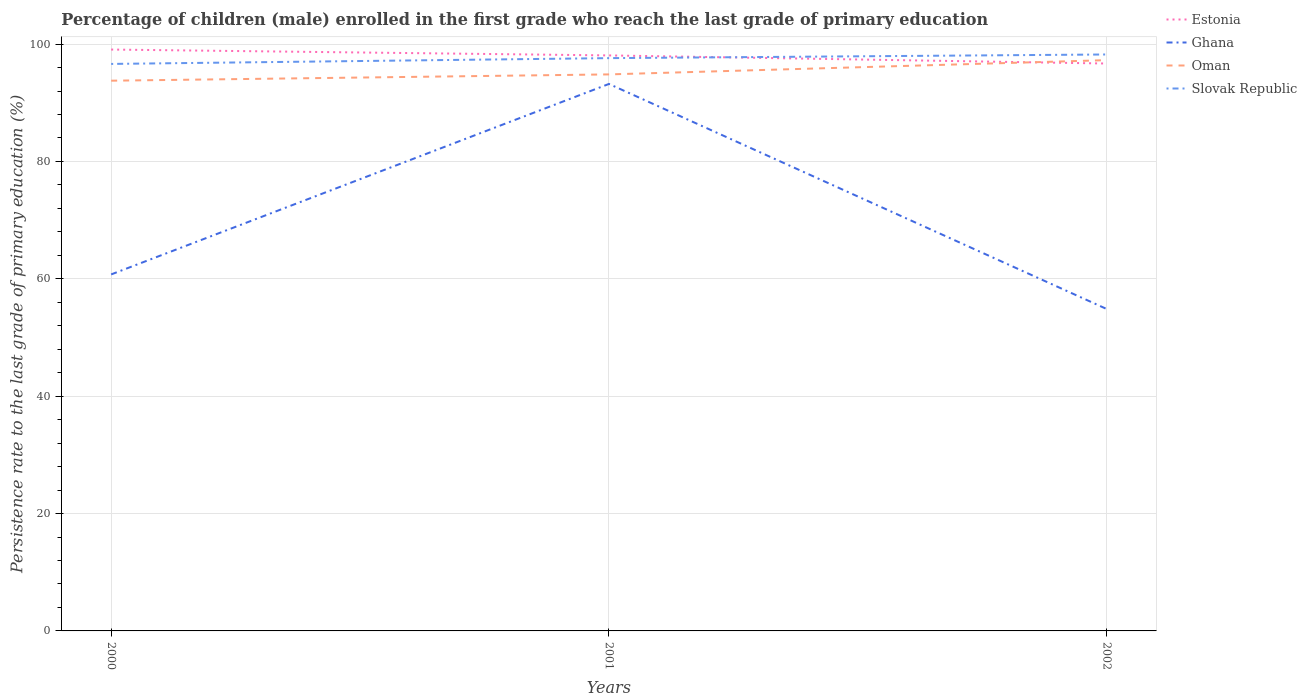Across all years, what is the maximum persistence rate of children in Slovak Republic?
Ensure brevity in your answer.  96.62. In which year was the persistence rate of children in Oman maximum?
Offer a terse response. 2000. What is the total persistence rate of children in Oman in the graph?
Provide a short and direct response. -2.43. What is the difference between the highest and the second highest persistence rate of children in Estonia?
Your answer should be compact. 2.38. How many years are there in the graph?
Your answer should be compact. 3. Are the values on the major ticks of Y-axis written in scientific E-notation?
Ensure brevity in your answer.  No. What is the title of the graph?
Ensure brevity in your answer.  Percentage of children (male) enrolled in the first grade who reach the last grade of primary education. Does "Guatemala" appear as one of the legend labels in the graph?
Offer a very short reply. No. What is the label or title of the X-axis?
Offer a very short reply. Years. What is the label or title of the Y-axis?
Your answer should be very brief. Persistence rate to the last grade of primary education (%). What is the Persistence rate to the last grade of primary education (%) of Estonia in 2000?
Offer a terse response. 99.07. What is the Persistence rate to the last grade of primary education (%) in Ghana in 2000?
Your answer should be compact. 60.75. What is the Persistence rate to the last grade of primary education (%) of Oman in 2000?
Your response must be concise. 93.76. What is the Persistence rate to the last grade of primary education (%) in Slovak Republic in 2000?
Your answer should be compact. 96.62. What is the Persistence rate to the last grade of primary education (%) of Estonia in 2001?
Your answer should be compact. 98.07. What is the Persistence rate to the last grade of primary education (%) of Ghana in 2001?
Offer a very short reply. 93.2. What is the Persistence rate to the last grade of primary education (%) in Oman in 2001?
Offer a terse response. 94.83. What is the Persistence rate to the last grade of primary education (%) of Slovak Republic in 2001?
Ensure brevity in your answer.  97.6. What is the Persistence rate to the last grade of primary education (%) of Estonia in 2002?
Your response must be concise. 96.68. What is the Persistence rate to the last grade of primary education (%) of Ghana in 2002?
Keep it short and to the point. 54.85. What is the Persistence rate to the last grade of primary education (%) in Oman in 2002?
Offer a very short reply. 97.26. What is the Persistence rate to the last grade of primary education (%) of Slovak Republic in 2002?
Make the answer very short. 98.23. Across all years, what is the maximum Persistence rate to the last grade of primary education (%) of Estonia?
Provide a short and direct response. 99.07. Across all years, what is the maximum Persistence rate to the last grade of primary education (%) in Ghana?
Keep it short and to the point. 93.2. Across all years, what is the maximum Persistence rate to the last grade of primary education (%) of Oman?
Offer a very short reply. 97.26. Across all years, what is the maximum Persistence rate to the last grade of primary education (%) of Slovak Republic?
Give a very brief answer. 98.23. Across all years, what is the minimum Persistence rate to the last grade of primary education (%) in Estonia?
Keep it short and to the point. 96.68. Across all years, what is the minimum Persistence rate to the last grade of primary education (%) in Ghana?
Make the answer very short. 54.85. Across all years, what is the minimum Persistence rate to the last grade of primary education (%) in Oman?
Keep it short and to the point. 93.76. Across all years, what is the minimum Persistence rate to the last grade of primary education (%) of Slovak Republic?
Give a very brief answer. 96.62. What is the total Persistence rate to the last grade of primary education (%) in Estonia in the graph?
Provide a short and direct response. 293.81. What is the total Persistence rate to the last grade of primary education (%) in Ghana in the graph?
Offer a terse response. 208.8. What is the total Persistence rate to the last grade of primary education (%) of Oman in the graph?
Your answer should be compact. 285.85. What is the total Persistence rate to the last grade of primary education (%) in Slovak Republic in the graph?
Ensure brevity in your answer.  292.44. What is the difference between the Persistence rate to the last grade of primary education (%) of Ghana in 2000 and that in 2001?
Provide a succinct answer. -32.46. What is the difference between the Persistence rate to the last grade of primary education (%) in Oman in 2000 and that in 2001?
Your answer should be very brief. -1.07. What is the difference between the Persistence rate to the last grade of primary education (%) of Slovak Republic in 2000 and that in 2001?
Your answer should be very brief. -0.99. What is the difference between the Persistence rate to the last grade of primary education (%) in Estonia in 2000 and that in 2002?
Ensure brevity in your answer.  2.38. What is the difference between the Persistence rate to the last grade of primary education (%) of Ghana in 2000 and that in 2002?
Provide a short and direct response. 5.9. What is the difference between the Persistence rate to the last grade of primary education (%) of Oman in 2000 and that in 2002?
Make the answer very short. -3.5. What is the difference between the Persistence rate to the last grade of primary education (%) in Slovak Republic in 2000 and that in 2002?
Your answer should be compact. -1.61. What is the difference between the Persistence rate to the last grade of primary education (%) of Estonia in 2001 and that in 2002?
Your answer should be compact. 1.38. What is the difference between the Persistence rate to the last grade of primary education (%) of Ghana in 2001 and that in 2002?
Provide a succinct answer. 38.35. What is the difference between the Persistence rate to the last grade of primary education (%) of Oman in 2001 and that in 2002?
Provide a succinct answer. -2.43. What is the difference between the Persistence rate to the last grade of primary education (%) in Slovak Republic in 2001 and that in 2002?
Your answer should be very brief. -0.62. What is the difference between the Persistence rate to the last grade of primary education (%) in Estonia in 2000 and the Persistence rate to the last grade of primary education (%) in Ghana in 2001?
Your response must be concise. 5.86. What is the difference between the Persistence rate to the last grade of primary education (%) in Estonia in 2000 and the Persistence rate to the last grade of primary education (%) in Oman in 2001?
Offer a very short reply. 4.24. What is the difference between the Persistence rate to the last grade of primary education (%) in Estonia in 2000 and the Persistence rate to the last grade of primary education (%) in Slovak Republic in 2001?
Give a very brief answer. 1.46. What is the difference between the Persistence rate to the last grade of primary education (%) in Ghana in 2000 and the Persistence rate to the last grade of primary education (%) in Oman in 2001?
Provide a succinct answer. -34.08. What is the difference between the Persistence rate to the last grade of primary education (%) of Ghana in 2000 and the Persistence rate to the last grade of primary education (%) of Slovak Republic in 2001?
Ensure brevity in your answer.  -36.86. What is the difference between the Persistence rate to the last grade of primary education (%) of Oman in 2000 and the Persistence rate to the last grade of primary education (%) of Slovak Republic in 2001?
Make the answer very short. -3.84. What is the difference between the Persistence rate to the last grade of primary education (%) of Estonia in 2000 and the Persistence rate to the last grade of primary education (%) of Ghana in 2002?
Offer a terse response. 44.21. What is the difference between the Persistence rate to the last grade of primary education (%) of Estonia in 2000 and the Persistence rate to the last grade of primary education (%) of Oman in 2002?
Provide a succinct answer. 1.8. What is the difference between the Persistence rate to the last grade of primary education (%) in Estonia in 2000 and the Persistence rate to the last grade of primary education (%) in Slovak Republic in 2002?
Offer a terse response. 0.84. What is the difference between the Persistence rate to the last grade of primary education (%) of Ghana in 2000 and the Persistence rate to the last grade of primary education (%) of Oman in 2002?
Ensure brevity in your answer.  -36.51. What is the difference between the Persistence rate to the last grade of primary education (%) in Ghana in 2000 and the Persistence rate to the last grade of primary education (%) in Slovak Republic in 2002?
Offer a terse response. -37.48. What is the difference between the Persistence rate to the last grade of primary education (%) in Oman in 2000 and the Persistence rate to the last grade of primary education (%) in Slovak Republic in 2002?
Keep it short and to the point. -4.47. What is the difference between the Persistence rate to the last grade of primary education (%) of Estonia in 2001 and the Persistence rate to the last grade of primary education (%) of Ghana in 2002?
Keep it short and to the point. 43.21. What is the difference between the Persistence rate to the last grade of primary education (%) of Estonia in 2001 and the Persistence rate to the last grade of primary education (%) of Oman in 2002?
Provide a succinct answer. 0.81. What is the difference between the Persistence rate to the last grade of primary education (%) of Estonia in 2001 and the Persistence rate to the last grade of primary education (%) of Slovak Republic in 2002?
Your answer should be very brief. -0.16. What is the difference between the Persistence rate to the last grade of primary education (%) of Ghana in 2001 and the Persistence rate to the last grade of primary education (%) of Oman in 2002?
Offer a very short reply. -4.06. What is the difference between the Persistence rate to the last grade of primary education (%) in Ghana in 2001 and the Persistence rate to the last grade of primary education (%) in Slovak Republic in 2002?
Offer a terse response. -5.02. What is the difference between the Persistence rate to the last grade of primary education (%) in Oman in 2001 and the Persistence rate to the last grade of primary education (%) in Slovak Republic in 2002?
Keep it short and to the point. -3.4. What is the average Persistence rate to the last grade of primary education (%) of Estonia per year?
Your answer should be compact. 97.94. What is the average Persistence rate to the last grade of primary education (%) in Ghana per year?
Provide a succinct answer. 69.6. What is the average Persistence rate to the last grade of primary education (%) of Oman per year?
Provide a succinct answer. 95.28. What is the average Persistence rate to the last grade of primary education (%) in Slovak Republic per year?
Provide a short and direct response. 97.48. In the year 2000, what is the difference between the Persistence rate to the last grade of primary education (%) of Estonia and Persistence rate to the last grade of primary education (%) of Ghana?
Make the answer very short. 38.32. In the year 2000, what is the difference between the Persistence rate to the last grade of primary education (%) of Estonia and Persistence rate to the last grade of primary education (%) of Oman?
Ensure brevity in your answer.  5.31. In the year 2000, what is the difference between the Persistence rate to the last grade of primary education (%) in Estonia and Persistence rate to the last grade of primary education (%) in Slovak Republic?
Provide a succinct answer. 2.45. In the year 2000, what is the difference between the Persistence rate to the last grade of primary education (%) of Ghana and Persistence rate to the last grade of primary education (%) of Oman?
Your answer should be compact. -33.01. In the year 2000, what is the difference between the Persistence rate to the last grade of primary education (%) in Ghana and Persistence rate to the last grade of primary education (%) in Slovak Republic?
Ensure brevity in your answer.  -35.87. In the year 2000, what is the difference between the Persistence rate to the last grade of primary education (%) of Oman and Persistence rate to the last grade of primary education (%) of Slovak Republic?
Offer a terse response. -2.86. In the year 2001, what is the difference between the Persistence rate to the last grade of primary education (%) in Estonia and Persistence rate to the last grade of primary education (%) in Ghana?
Ensure brevity in your answer.  4.86. In the year 2001, what is the difference between the Persistence rate to the last grade of primary education (%) in Estonia and Persistence rate to the last grade of primary education (%) in Oman?
Keep it short and to the point. 3.24. In the year 2001, what is the difference between the Persistence rate to the last grade of primary education (%) in Estonia and Persistence rate to the last grade of primary education (%) in Slovak Republic?
Give a very brief answer. 0.46. In the year 2001, what is the difference between the Persistence rate to the last grade of primary education (%) in Ghana and Persistence rate to the last grade of primary education (%) in Oman?
Offer a terse response. -1.63. In the year 2001, what is the difference between the Persistence rate to the last grade of primary education (%) of Ghana and Persistence rate to the last grade of primary education (%) of Slovak Republic?
Offer a terse response. -4.4. In the year 2001, what is the difference between the Persistence rate to the last grade of primary education (%) of Oman and Persistence rate to the last grade of primary education (%) of Slovak Republic?
Provide a short and direct response. -2.77. In the year 2002, what is the difference between the Persistence rate to the last grade of primary education (%) in Estonia and Persistence rate to the last grade of primary education (%) in Ghana?
Make the answer very short. 41.83. In the year 2002, what is the difference between the Persistence rate to the last grade of primary education (%) of Estonia and Persistence rate to the last grade of primary education (%) of Oman?
Offer a very short reply. -0.58. In the year 2002, what is the difference between the Persistence rate to the last grade of primary education (%) of Estonia and Persistence rate to the last grade of primary education (%) of Slovak Republic?
Your response must be concise. -1.54. In the year 2002, what is the difference between the Persistence rate to the last grade of primary education (%) in Ghana and Persistence rate to the last grade of primary education (%) in Oman?
Provide a succinct answer. -42.41. In the year 2002, what is the difference between the Persistence rate to the last grade of primary education (%) in Ghana and Persistence rate to the last grade of primary education (%) in Slovak Republic?
Offer a very short reply. -43.37. In the year 2002, what is the difference between the Persistence rate to the last grade of primary education (%) in Oman and Persistence rate to the last grade of primary education (%) in Slovak Republic?
Keep it short and to the point. -0.96. What is the ratio of the Persistence rate to the last grade of primary education (%) of Estonia in 2000 to that in 2001?
Provide a short and direct response. 1.01. What is the ratio of the Persistence rate to the last grade of primary education (%) in Ghana in 2000 to that in 2001?
Your answer should be compact. 0.65. What is the ratio of the Persistence rate to the last grade of primary education (%) of Oman in 2000 to that in 2001?
Your response must be concise. 0.99. What is the ratio of the Persistence rate to the last grade of primary education (%) of Estonia in 2000 to that in 2002?
Provide a succinct answer. 1.02. What is the ratio of the Persistence rate to the last grade of primary education (%) in Ghana in 2000 to that in 2002?
Your response must be concise. 1.11. What is the ratio of the Persistence rate to the last grade of primary education (%) of Oman in 2000 to that in 2002?
Give a very brief answer. 0.96. What is the ratio of the Persistence rate to the last grade of primary education (%) in Slovak Republic in 2000 to that in 2002?
Give a very brief answer. 0.98. What is the ratio of the Persistence rate to the last grade of primary education (%) of Estonia in 2001 to that in 2002?
Make the answer very short. 1.01. What is the ratio of the Persistence rate to the last grade of primary education (%) in Ghana in 2001 to that in 2002?
Your answer should be very brief. 1.7. What is the ratio of the Persistence rate to the last grade of primary education (%) in Oman in 2001 to that in 2002?
Make the answer very short. 0.97. What is the difference between the highest and the second highest Persistence rate to the last grade of primary education (%) of Estonia?
Ensure brevity in your answer.  1. What is the difference between the highest and the second highest Persistence rate to the last grade of primary education (%) in Ghana?
Ensure brevity in your answer.  32.46. What is the difference between the highest and the second highest Persistence rate to the last grade of primary education (%) in Oman?
Your answer should be very brief. 2.43. What is the difference between the highest and the second highest Persistence rate to the last grade of primary education (%) in Slovak Republic?
Make the answer very short. 0.62. What is the difference between the highest and the lowest Persistence rate to the last grade of primary education (%) in Estonia?
Offer a terse response. 2.38. What is the difference between the highest and the lowest Persistence rate to the last grade of primary education (%) in Ghana?
Offer a terse response. 38.35. What is the difference between the highest and the lowest Persistence rate to the last grade of primary education (%) of Oman?
Your answer should be compact. 3.5. What is the difference between the highest and the lowest Persistence rate to the last grade of primary education (%) in Slovak Republic?
Provide a succinct answer. 1.61. 